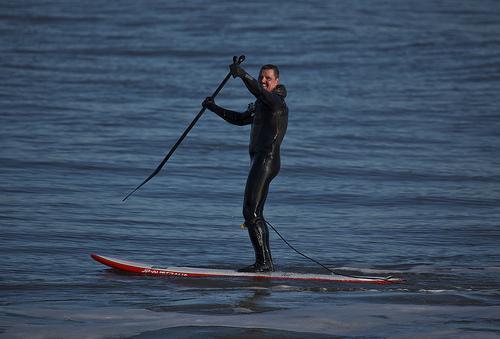How many are paddle boarding?
Give a very brief answer. 1. How many paddles?
Give a very brief answer. 1. 